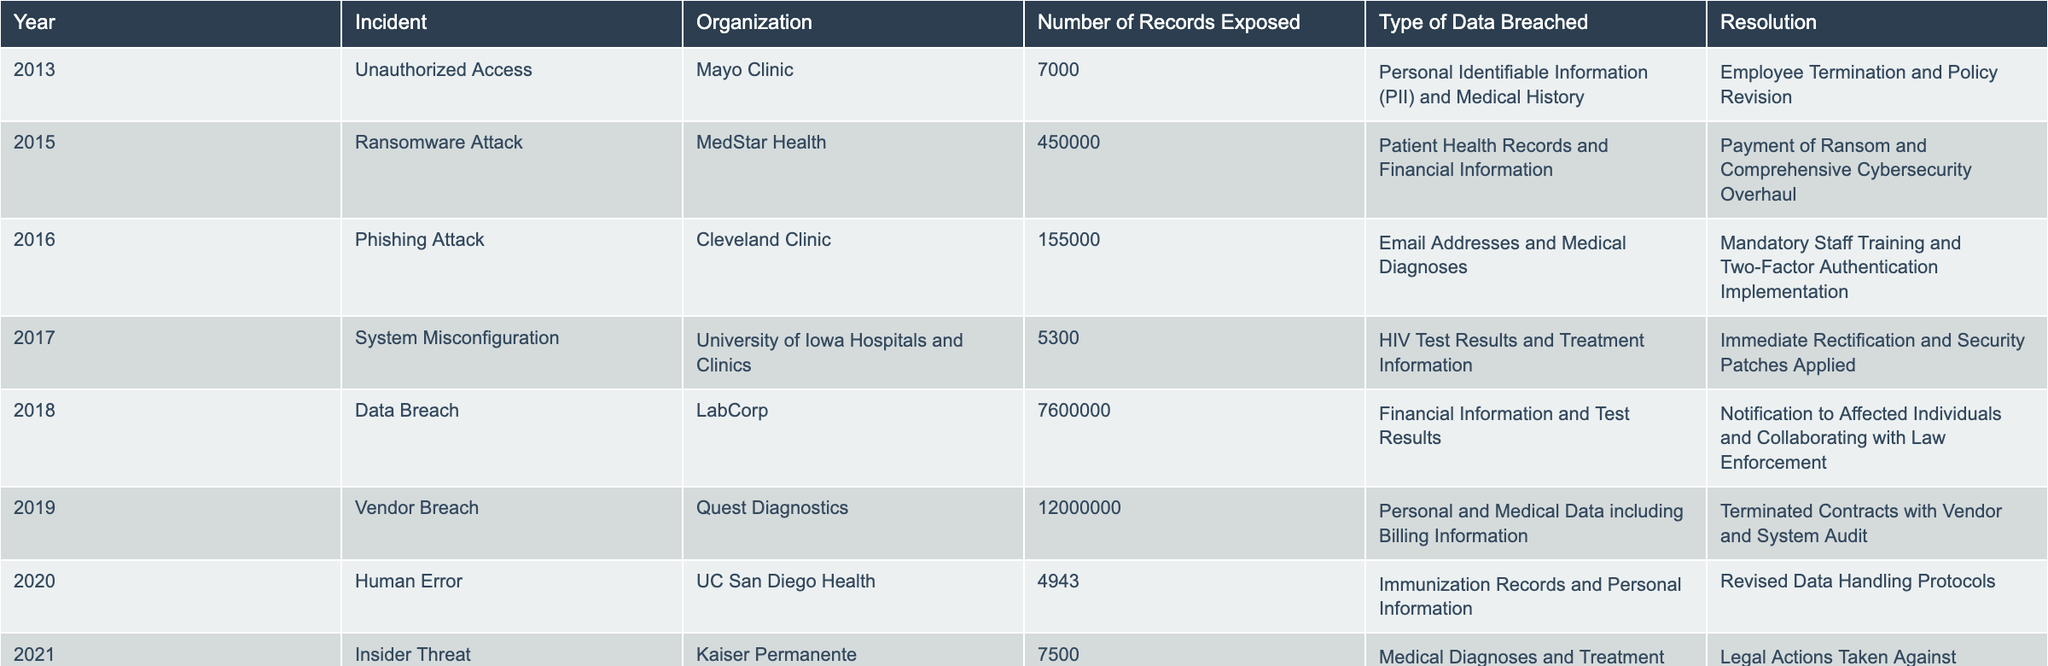What incident occurred in 2018? Referring to the table, the incident that took place in 2018 is a data breach involving LabCorp.
Answer: Data Breach How many records were exposed in the 2019 vendor breach? By looking at the 2019 row in the table, it shows that during the vendor breach by Quest Diagnostics, 12,000,000 records were exposed.
Answer: 12,000,000 Is human error the cause of any incident listed? Yes, the table indicates that in 2020, the incident was attributed to human error at UC San Diego Health.
Answer: Yes Which organization experienced the highest number of records exposed, and how many were they? The 2018 data breach at LabCorp had the highest number of records exposed, which was 7,600,000. Therefore, LabCorp is the organization with the highest exposure.
Answer: LabCorp, 7,600,000 What is the average number of records exposed across all incidents recorded in the table? First, we sum the number of records exposed: 7,000 + 450,000 + 155,000 + 5,300 + 7,600,000 + 12,000,000 + 4,943 + 7,500 + 290,000 + 120,000 = 20,244,743. Then, there are 10 incidents in total, so the average is 20,244,743 divided by 10, which equals 2,024,474.3.
Answer: 2,024,474.3 Was there any incident in 2022 that involved hacking? Yes, in 2022 there was a hacking incident reported involving MHealth Fairview.
Answer: Yes 